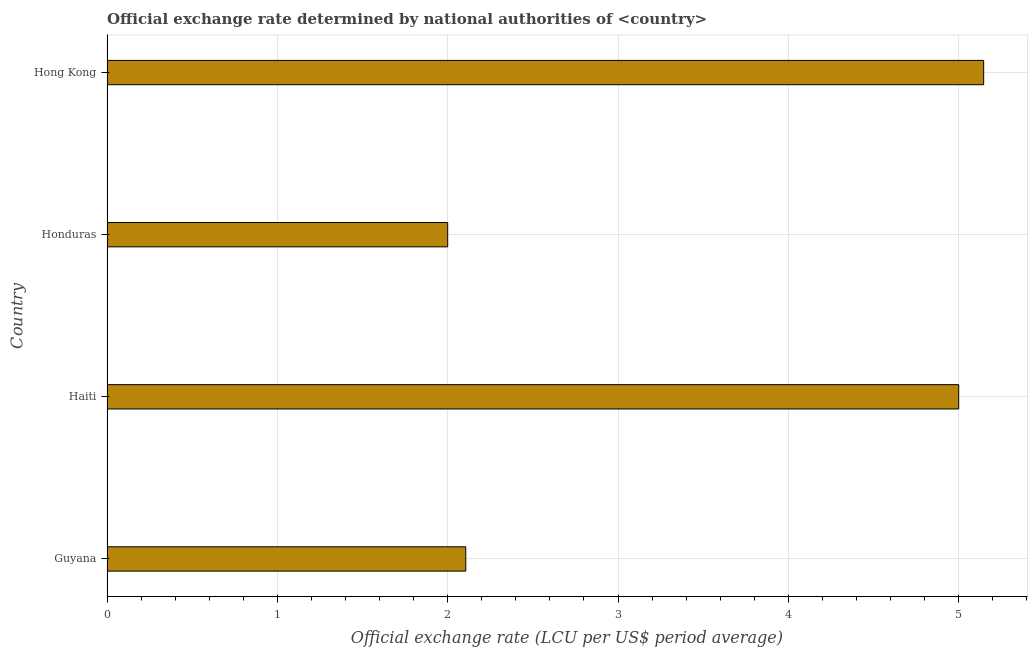Does the graph contain any zero values?
Your response must be concise. No. Does the graph contain grids?
Ensure brevity in your answer.  Yes. What is the title of the graph?
Provide a succinct answer. Official exchange rate determined by national authorities of <country>. What is the label or title of the X-axis?
Make the answer very short. Official exchange rate (LCU per US$ period average). What is the official exchange rate in Guyana?
Make the answer very short. 2.11. Across all countries, what is the maximum official exchange rate?
Give a very brief answer. 5.15. Across all countries, what is the minimum official exchange rate?
Keep it short and to the point. 2. In which country was the official exchange rate maximum?
Offer a terse response. Hong Kong. In which country was the official exchange rate minimum?
Offer a very short reply. Honduras. What is the sum of the official exchange rate?
Provide a succinct answer. 14.25. What is the average official exchange rate per country?
Your response must be concise. 3.56. What is the median official exchange rate?
Ensure brevity in your answer.  3.55. Is the official exchange rate in Haiti less than that in Hong Kong?
Your answer should be compact. Yes. What is the difference between the highest and the second highest official exchange rate?
Your answer should be very brief. 0.15. What is the difference between the highest and the lowest official exchange rate?
Provide a succinct answer. 3.15. In how many countries, is the official exchange rate greater than the average official exchange rate taken over all countries?
Provide a short and direct response. 2. Are all the bars in the graph horizontal?
Your response must be concise. Yes. What is the difference between two consecutive major ticks on the X-axis?
Ensure brevity in your answer.  1. Are the values on the major ticks of X-axis written in scientific E-notation?
Provide a succinct answer. No. What is the Official exchange rate (LCU per US$ period average) of Guyana?
Offer a very short reply. 2.11. What is the Official exchange rate (LCU per US$ period average) in Haiti?
Your answer should be very brief. 5. What is the Official exchange rate (LCU per US$ period average) in Honduras?
Give a very brief answer. 2. What is the Official exchange rate (LCU per US$ period average) of Hong Kong?
Ensure brevity in your answer.  5.15. What is the difference between the Official exchange rate (LCU per US$ period average) in Guyana and Haiti?
Offer a very short reply. -2.89. What is the difference between the Official exchange rate (LCU per US$ period average) in Guyana and Honduras?
Provide a short and direct response. 0.11. What is the difference between the Official exchange rate (LCU per US$ period average) in Guyana and Hong Kong?
Your response must be concise. -3.04. What is the difference between the Official exchange rate (LCU per US$ period average) in Haiti and Hong Kong?
Make the answer very short. -0.15. What is the difference between the Official exchange rate (LCU per US$ period average) in Honduras and Hong Kong?
Ensure brevity in your answer.  -3.15. What is the ratio of the Official exchange rate (LCU per US$ period average) in Guyana to that in Haiti?
Keep it short and to the point. 0.42. What is the ratio of the Official exchange rate (LCU per US$ period average) in Guyana to that in Honduras?
Your answer should be very brief. 1.05. What is the ratio of the Official exchange rate (LCU per US$ period average) in Guyana to that in Hong Kong?
Make the answer very short. 0.41. What is the ratio of the Official exchange rate (LCU per US$ period average) in Haiti to that in Honduras?
Provide a short and direct response. 2.5. What is the ratio of the Official exchange rate (LCU per US$ period average) in Honduras to that in Hong Kong?
Your answer should be compact. 0.39. 